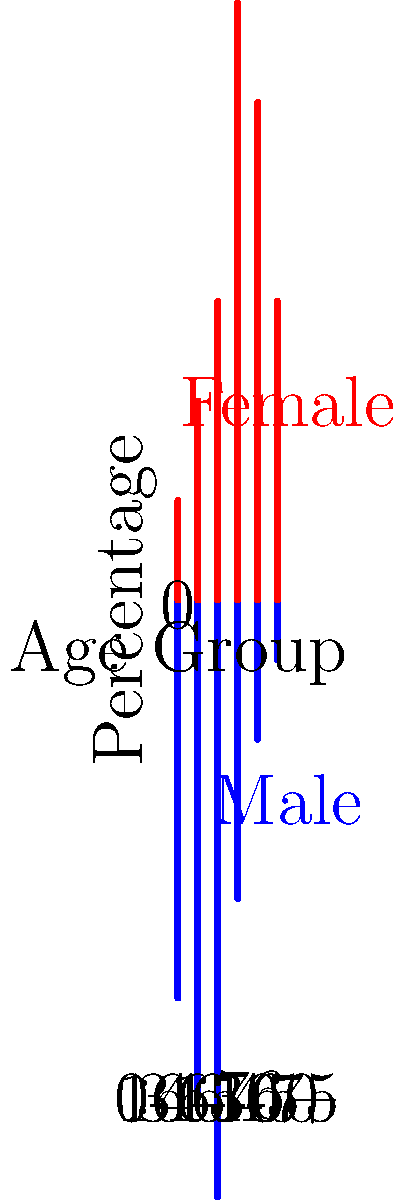As an advertising executive aiming to maximize profit, which age group and gender should you target for a controversial luxury sports car campaign based on the population pyramid shown? To determine the most profitable target audience for a controversial luxury sports car campaign, we need to consider several factors:

1. Age group: Luxury sports cars typically appeal to adults with high disposable income.
2. Gender: Historically, sports cars have been marketed more towards males, though this is changing.
3. Population size: Larger population segments offer more potential customers.
4. Controversy potential: Younger adults are often more receptive to controversial campaigns.

Analyzing the population pyramid:

1. The 31-45 age group has the largest male population (30%).
2. This age group is likely to have established careers and higher disposable income.
3. They are young enough to be receptive to controversial marketing but old enough to afford luxury items.
4. The male skew in this age group aligns with traditional sports car marketing.

While targeting women or other age groups could be innovative, the goal is to maximize profit. Therefore, the largest, most traditionally receptive demographic would be the most profitable choice for a controversial luxury sports car campaign.
Answer: Males aged 31-45 